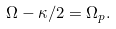Convert formula to latex. <formula><loc_0><loc_0><loc_500><loc_500>\Omega - \kappa / 2 = \Omega _ { p } .</formula> 